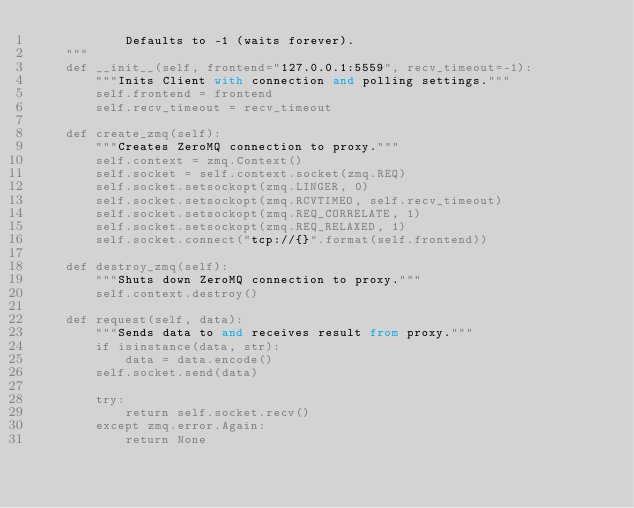<code> <loc_0><loc_0><loc_500><loc_500><_Python_>            Defaults to -1 (waits forever).
    """
    def __init__(self, frontend="127.0.0.1:5559", recv_timeout=-1):
        """Inits Client with connection and polling settings."""
        self.frontend = frontend
        self.recv_timeout = recv_timeout

    def create_zmq(self):
        """Creates ZeroMQ connection to proxy."""
        self.context = zmq.Context()
        self.socket = self.context.socket(zmq.REQ)
        self.socket.setsockopt(zmq.LINGER, 0)
        self.socket.setsockopt(zmq.RCVTIMEO, self.recv_timeout)
        self.socket.setsockopt(zmq.REQ_CORRELATE, 1)
        self.socket.setsockopt(zmq.REQ_RELAXED, 1)
        self.socket.connect("tcp://{}".format(self.frontend))

    def destroy_zmq(self):
        """Shuts down ZeroMQ connection to proxy."""
        self.context.destroy()

    def request(self, data):
        """Sends data to and receives result from proxy."""
        if isinstance(data, str):
            data = data.encode()
        self.socket.send(data)

        try:
            return self.socket.recv()
        except zmq.error.Again:
            return None
</code> 